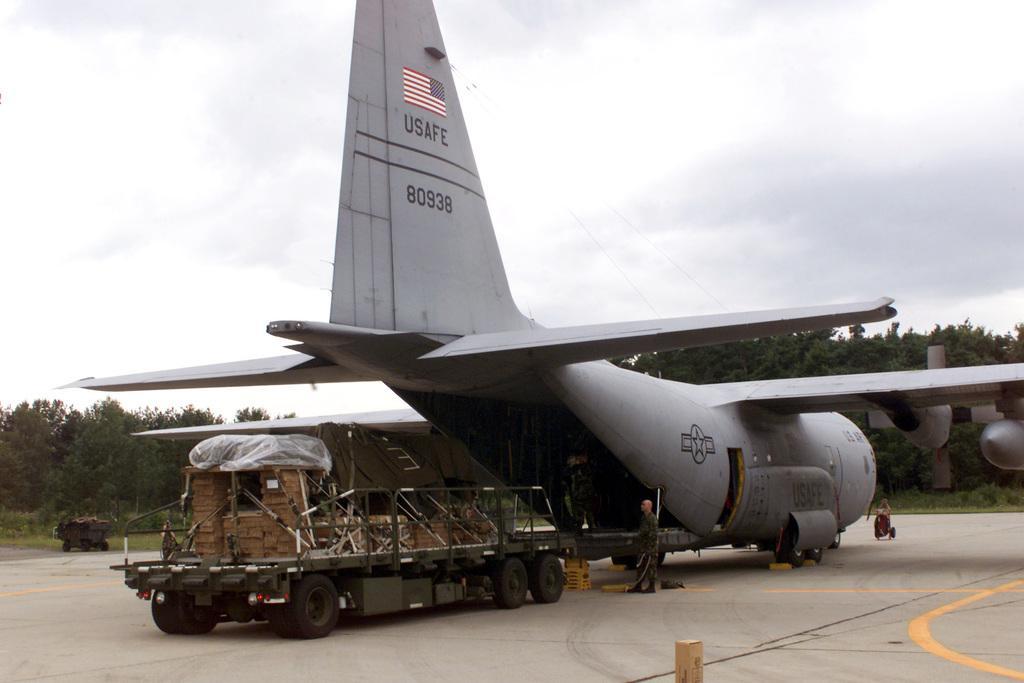In one or two sentences, can you explain what this image depicts? In this picture there is an aeroplane in the center of the image and there are trees in the background area of the image. 